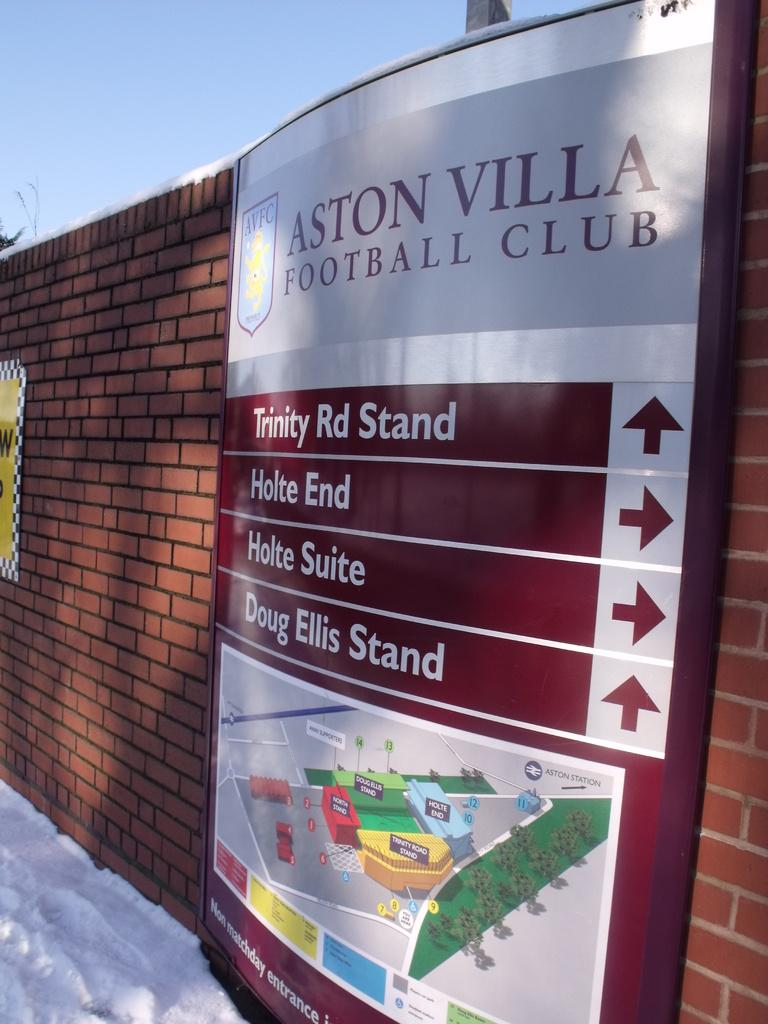<image>
Write a terse but informative summary of the picture. A sign for the Aston Villa Football Club. 